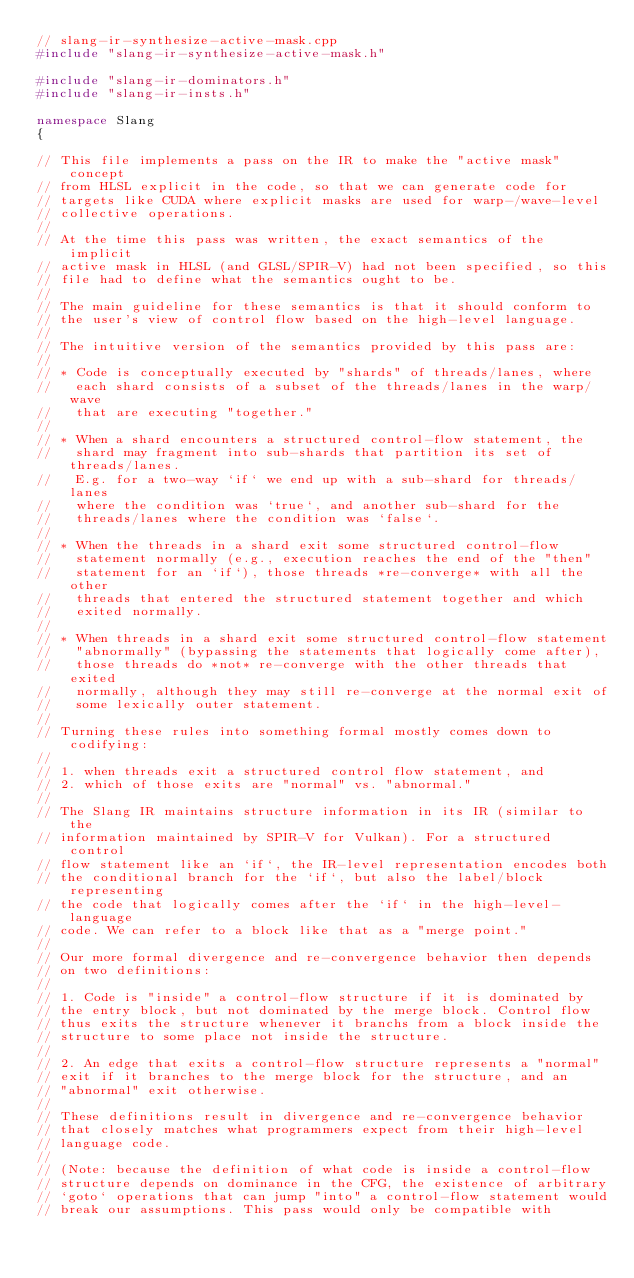<code> <loc_0><loc_0><loc_500><loc_500><_C++_>// slang-ir-synthesize-active-mask.cpp
#include "slang-ir-synthesize-active-mask.h"

#include "slang-ir-dominators.h"
#include "slang-ir-insts.h"

namespace Slang
{

// This file implements a pass on the IR to make the "active mask" concept
// from HLSL explicit in the code, so that we can generate code for
// targets like CUDA where explicit masks are used for warp-/wave-level
// collective operations.
//
// At the time this pass was written, the exact semantics of the implicit
// active mask in HLSL (and GLSL/SPIR-V) had not been specified, so this
// file had to define what the semantics ought to be.
//
// The main guideline for these semantics is that it should conform to
// the user's view of control flow based on the high-level language.
//
// The intuitive version of the semantics provided by this pass are:
//
// * Code is conceptually executed by "shards" of threads/lanes, where
//   each shard consists of a subset of the threads/lanes in the warp/wave
//   that are executing "together."
//
// * When a shard encounters a structured control-flow statement, the
//   shard may fragment into sub-shards that partition its set of threads/lanes.
//   E.g. for a two-way `if` we end up with a sub-shard for threads/lanes
//   where the condition was `true`, and another sub-shard for the
//   threads/lanes where the condition was `false`.
//
// * When the threads in a shard exit some structured control-flow
//   statement normally (e.g., execution reaches the end of the "then"
//   statement for an `if`), those threads *re-converge* with all the other
//   threads that entered the structured statement together and which
//   exited normally.
//
// * When threads in a shard exit some structured control-flow statement
//   "abnormally" (bypassing the statements that logically come after),
//   those threads do *not* re-converge with the other threads that exited
//   normally, although they may still re-converge at the normal exit of
//   some lexically outer statement.
//
// Turning these rules into something formal mostly comes down to codifying:
//
// 1. when threads exit a structured control flow statement, and
// 2. which of those exits are "normal" vs. "abnormal."
//
// The Slang IR maintains structure information in its IR (similar to the
// information maintained by SPIR-V for Vulkan). For a structured control
// flow statement like an `if`, the IR-level representation encodes both
// the conditional branch for the `if`, but also the label/block representing
// the code that logically comes after the `if` in the high-level-language
// code. We can refer to a block like that as a "merge point."
//
// Our more formal divergence and re-convergence behavior then depends
// on two definitions:
//
// 1. Code is "inside" a control-flow structure if it is dominated by
// the entry block, but not dominated by the merge block. Control flow
// thus exits the structure whenever it branchs from a block inside the
// structure to some place not inside the structure.
//
// 2. An edge that exits a control-flow structure represents a "normal"
// exit if it branches to the merge block for the structure, and an
// "abnormal" exit otherwise.
//
// These definitions result in divergence and re-convergence behavior
// that closely matches what programmers expect from their high-level
// language code.
//
// (Note: because the definition of what code is inside a control-flow
// structure depends on dominance in the CFG, the existence of arbitrary
// `goto` operations that can jump "into" a control-flow statement would
// break our assumptions. This pass would only be compatible with</code> 